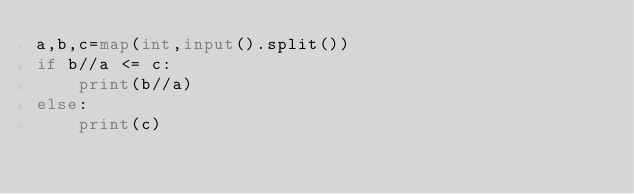<code> <loc_0><loc_0><loc_500><loc_500><_Python_>a,b,c=map(int,input().split())
if b//a <= c:
    print(b//a)
else:
    print(c)</code> 